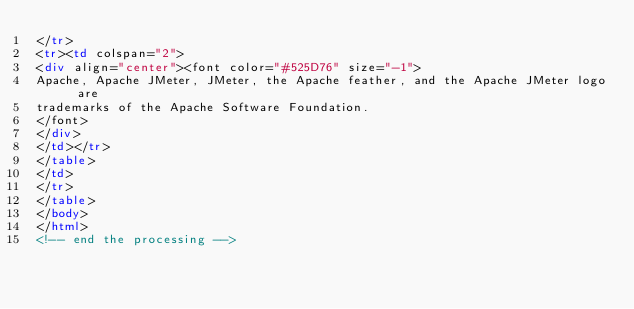<code> <loc_0><loc_0><loc_500><loc_500><_HTML_></tr>
<tr><td colspan="2">
<div align="center"><font color="#525D76" size="-1">
Apache, Apache JMeter, JMeter, the Apache feather, and the Apache JMeter logo are
trademarks of the Apache Software Foundation.
</font>
</div>
</td></tr>
</table>
</td>
</tr>
</table>
</body>
</html>
<!-- end the processing -->














































</code> 